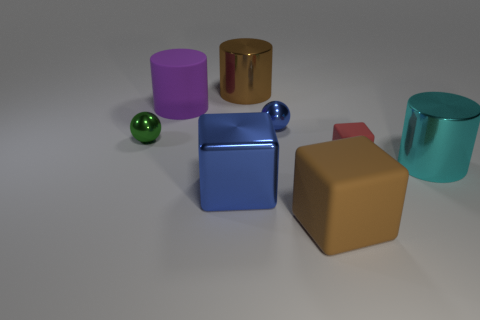Are there the same number of small matte blocks behind the big purple matte object and red matte cubes that are in front of the tiny block?
Offer a terse response. Yes. There is a green object that is the same size as the red cube; what shape is it?
Make the answer very short. Sphere. Is there another large matte cylinder that has the same color as the matte cylinder?
Make the answer very short. No. What is the shape of the large brown thing that is behind the blue metal ball?
Give a very brief answer. Cylinder. The matte cylinder has what color?
Ensure brevity in your answer.  Purple. There is a large block that is the same material as the big purple cylinder; what is its color?
Provide a succinct answer. Brown. How many tiny blocks are made of the same material as the blue sphere?
Make the answer very short. 0. There is a large blue block; how many large cyan cylinders are on the left side of it?
Your answer should be very brief. 0. Are the cylinder behind the big matte cylinder and the big cylinder to the right of the tiny matte thing made of the same material?
Ensure brevity in your answer.  Yes. Are there more metallic balls that are on the left side of the green metallic ball than big brown cylinders on the right side of the large rubber block?
Offer a very short reply. No. 